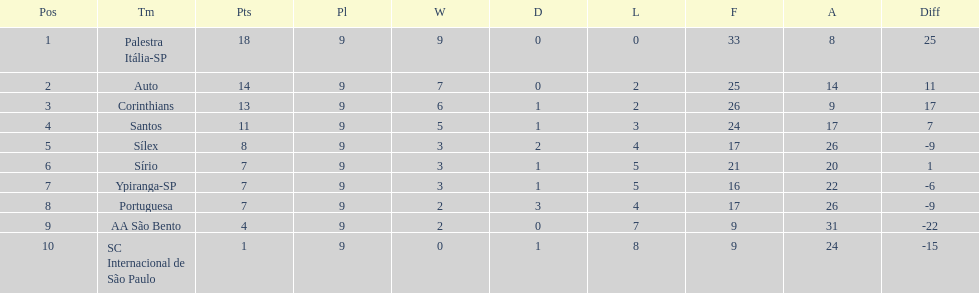What was the number of points the brazilian football team received automatically in 1926? 14. 